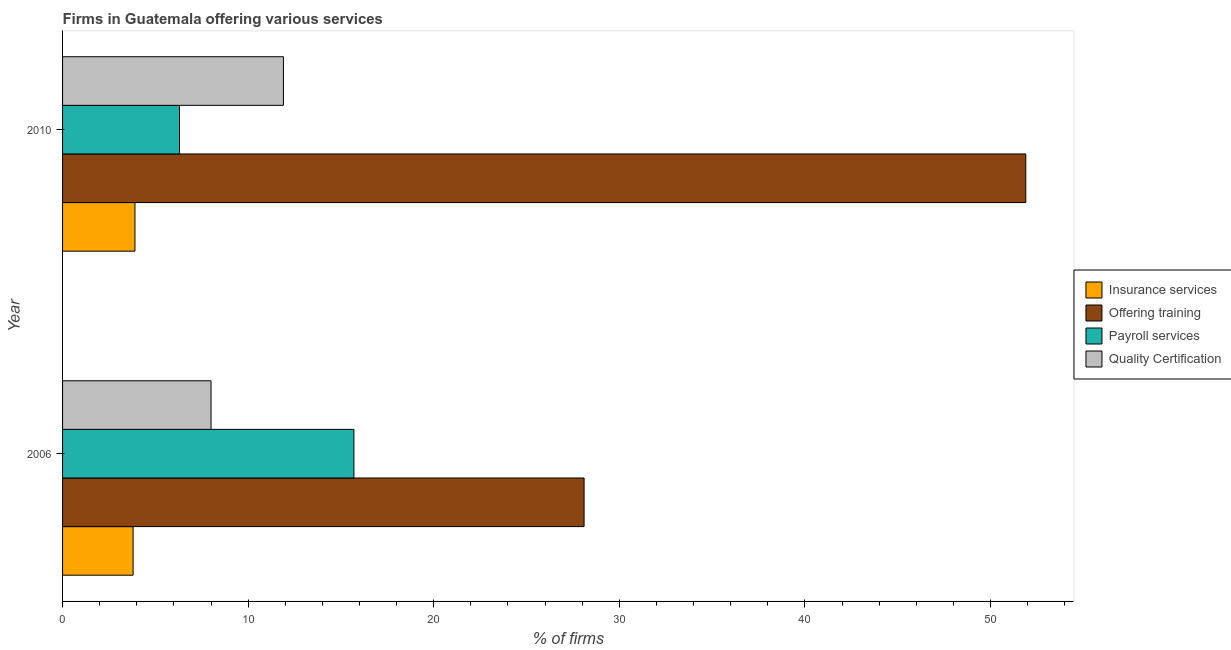How many groups of bars are there?
Give a very brief answer. 2. How many bars are there on the 2nd tick from the bottom?
Offer a very short reply. 4. What is the percentage of firms offering insurance services in 2006?
Offer a terse response. 3.8. Across all years, what is the minimum percentage of firms offering training?
Keep it short and to the point. 28.1. What is the difference between the percentage of firms offering training in 2006 and that in 2010?
Ensure brevity in your answer.  -23.8. What is the average percentage of firms offering quality certification per year?
Keep it short and to the point. 9.95. In how many years, is the percentage of firms offering training greater than 20 %?
Offer a very short reply. 2. What is the ratio of the percentage of firms offering insurance services in 2006 to that in 2010?
Provide a short and direct response. 0.97. Is the difference between the percentage of firms offering training in 2006 and 2010 greater than the difference between the percentage of firms offering insurance services in 2006 and 2010?
Your answer should be compact. No. In how many years, is the percentage of firms offering training greater than the average percentage of firms offering training taken over all years?
Provide a short and direct response. 1. What does the 3rd bar from the top in 2006 represents?
Keep it short and to the point. Offering training. What does the 2nd bar from the bottom in 2006 represents?
Your answer should be very brief. Offering training. How many bars are there?
Give a very brief answer. 8. What is the difference between two consecutive major ticks on the X-axis?
Offer a very short reply. 10. Does the graph contain any zero values?
Offer a very short reply. No. Where does the legend appear in the graph?
Make the answer very short. Center right. How many legend labels are there?
Keep it short and to the point. 4. What is the title of the graph?
Keep it short and to the point. Firms in Guatemala offering various services . Does "Switzerland" appear as one of the legend labels in the graph?
Give a very brief answer. No. What is the label or title of the X-axis?
Provide a short and direct response. % of firms. What is the label or title of the Y-axis?
Your response must be concise. Year. What is the % of firms of Insurance services in 2006?
Give a very brief answer. 3.8. What is the % of firms of Offering training in 2006?
Your response must be concise. 28.1. What is the % of firms in Payroll services in 2006?
Offer a terse response. 15.7. What is the % of firms of Offering training in 2010?
Make the answer very short. 51.9. Across all years, what is the maximum % of firms in Insurance services?
Provide a succinct answer. 3.9. Across all years, what is the maximum % of firms of Offering training?
Your answer should be compact. 51.9. Across all years, what is the maximum % of firms of Payroll services?
Your answer should be very brief. 15.7. Across all years, what is the minimum % of firms of Offering training?
Ensure brevity in your answer.  28.1. What is the total % of firms in Insurance services in the graph?
Offer a terse response. 7.7. What is the total % of firms of Offering training in the graph?
Ensure brevity in your answer.  80. What is the total % of firms in Quality Certification in the graph?
Offer a very short reply. 19.9. What is the difference between the % of firms of Offering training in 2006 and that in 2010?
Offer a terse response. -23.8. What is the difference between the % of firms of Quality Certification in 2006 and that in 2010?
Keep it short and to the point. -3.9. What is the difference between the % of firms in Insurance services in 2006 and the % of firms in Offering training in 2010?
Keep it short and to the point. -48.1. What is the difference between the % of firms in Insurance services in 2006 and the % of firms in Payroll services in 2010?
Your answer should be very brief. -2.5. What is the difference between the % of firms of Insurance services in 2006 and the % of firms of Quality Certification in 2010?
Provide a succinct answer. -8.1. What is the difference between the % of firms of Offering training in 2006 and the % of firms of Payroll services in 2010?
Offer a very short reply. 21.8. What is the difference between the % of firms of Payroll services in 2006 and the % of firms of Quality Certification in 2010?
Offer a terse response. 3.8. What is the average % of firms of Insurance services per year?
Ensure brevity in your answer.  3.85. What is the average % of firms in Offering training per year?
Your answer should be compact. 40. What is the average % of firms of Payroll services per year?
Provide a short and direct response. 11. What is the average % of firms in Quality Certification per year?
Ensure brevity in your answer.  9.95. In the year 2006, what is the difference between the % of firms of Insurance services and % of firms of Offering training?
Keep it short and to the point. -24.3. In the year 2006, what is the difference between the % of firms in Offering training and % of firms in Payroll services?
Give a very brief answer. 12.4. In the year 2006, what is the difference between the % of firms of Offering training and % of firms of Quality Certification?
Your response must be concise. 20.1. In the year 2006, what is the difference between the % of firms in Payroll services and % of firms in Quality Certification?
Make the answer very short. 7.7. In the year 2010, what is the difference between the % of firms in Insurance services and % of firms in Offering training?
Make the answer very short. -48. In the year 2010, what is the difference between the % of firms in Insurance services and % of firms in Payroll services?
Give a very brief answer. -2.4. In the year 2010, what is the difference between the % of firms in Offering training and % of firms in Payroll services?
Your answer should be compact. 45.6. In the year 2010, what is the difference between the % of firms in Offering training and % of firms in Quality Certification?
Your answer should be very brief. 40. What is the ratio of the % of firms of Insurance services in 2006 to that in 2010?
Offer a terse response. 0.97. What is the ratio of the % of firms of Offering training in 2006 to that in 2010?
Provide a succinct answer. 0.54. What is the ratio of the % of firms in Payroll services in 2006 to that in 2010?
Your answer should be very brief. 2.49. What is the ratio of the % of firms in Quality Certification in 2006 to that in 2010?
Make the answer very short. 0.67. What is the difference between the highest and the second highest % of firms of Insurance services?
Your response must be concise. 0.1. What is the difference between the highest and the second highest % of firms in Offering training?
Keep it short and to the point. 23.8. What is the difference between the highest and the second highest % of firms in Payroll services?
Offer a very short reply. 9.4. What is the difference between the highest and the lowest % of firms in Offering training?
Your response must be concise. 23.8. What is the difference between the highest and the lowest % of firms in Payroll services?
Make the answer very short. 9.4. What is the difference between the highest and the lowest % of firms of Quality Certification?
Give a very brief answer. 3.9. 